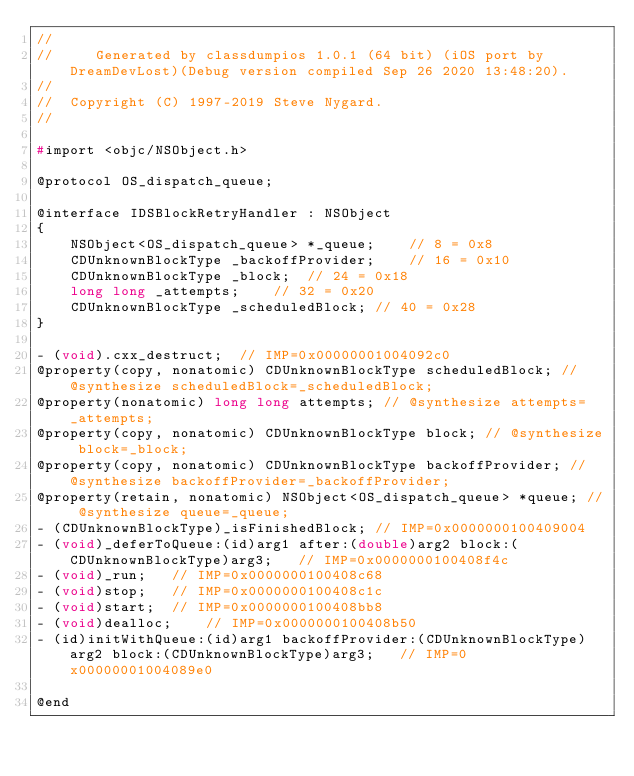<code> <loc_0><loc_0><loc_500><loc_500><_C_>//
//     Generated by classdumpios 1.0.1 (64 bit) (iOS port by DreamDevLost)(Debug version compiled Sep 26 2020 13:48:20).
//
//  Copyright (C) 1997-2019 Steve Nygard.
//

#import <objc/NSObject.h>

@protocol OS_dispatch_queue;

@interface IDSBlockRetryHandler : NSObject
{
    NSObject<OS_dispatch_queue> *_queue;	// 8 = 0x8
    CDUnknownBlockType _backoffProvider;	// 16 = 0x10
    CDUnknownBlockType _block;	// 24 = 0x18
    long long _attempts;	// 32 = 0x20
    CDUnknownBlockType _scheduledBlock;	// 40 = 0x28
}

- (void).cxx_destruct;	// IMP=0x00000001004092c0
@property(copy, nonatomic) CDUnknownBlockType scheduledBlock; // @synthesize scheduledBlock=_scheduledBlock;
@property(nonatomic) long long attempts; // @synthesize attempts=_attempts;
@property(copy, nonatomic) CDUnknownBlockType block; // @synthesize block=_block;
@property(copy, nonatomic) CDUnknownBlockType backoffProvider; // @synthesize backoffProvider=_backoffProvider;
@property(retain, nonatomic) NSObject<OS_dispatch_queue> *queue; // @synthesize queue=_queue;
- (CDUnknownBlockType)_isFinishedBlock;	// IMP=0x0000000100409004
- (void)_deferToQueue:(id)arg1 after:(double)arg2 block:(CDUnknownBlockType)arg3;	// IMP=0x0000000100408f4c
- (void)_run;	// IMP=0x0000000100408c68
- (void)stop;	// IMP=0x0000000100408c1c
- (void)start;	// IMP=0x0000000100408bb8
- (void)dealloc;	// IMP=0x0000000100408b50
- (id)initWithQueue:(id)arg1 backoffProvider:(CDUnknownBlockType)arg2 block:(CDUnknownBlockType)arg3;	// IMP=0x00000001004089e0

@end

</code> 